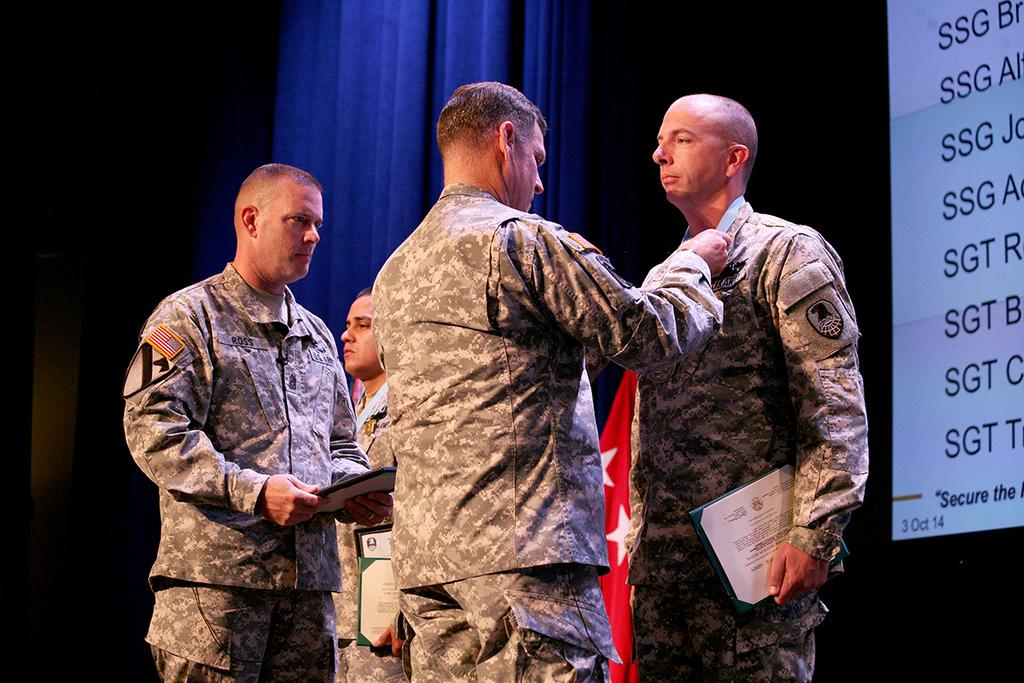How many people are present in the image? There are four persons standing in the image. What are the persons holding in the image? The persons are holding objects. What type of window treatment can be seen in the image? There are curtains visible in the image. What symbol or emblem can be seen in the image? There is a flag in the image. What type of display is present in the image? There is a screen with text in the image. Where is the sofa located in the image? There is no sofa present in the image. What is the wish of the persons in the image? The image does not provide information about the wishes of the persons. 